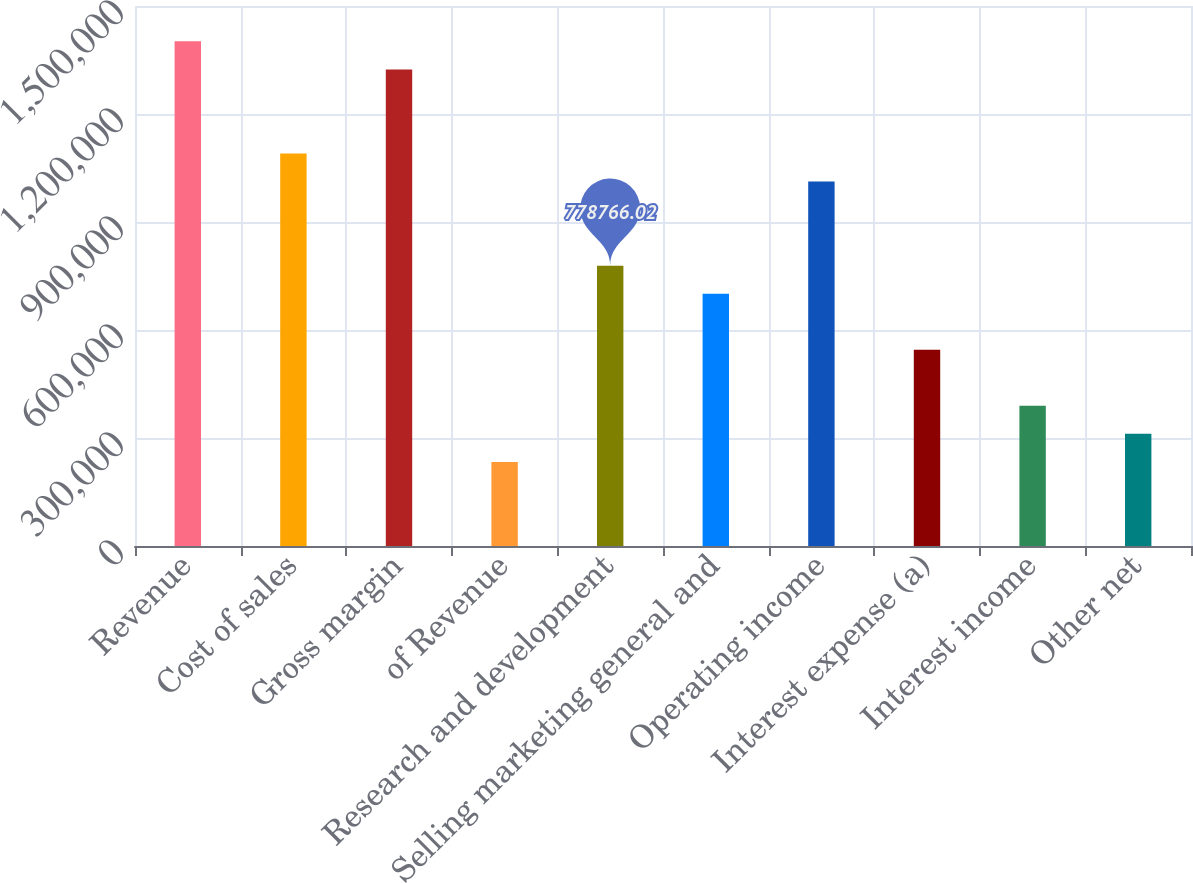Convert chart. <chart><loc_0><loc_0><loc_500><loc_500><bar_chart><fcel>Revenue<fcel>Cost of sales<fcel>Gross margin<fcel>of Revenue<fcel>Research and development<fcel>Selling marketing general and<fcel>Operating income<fcel>Interest expense (a)<fcel>Interest income<fcel>Other net<nl><fcel>1.40178e+06<fcel>1.09027e+06<fcel>1.3239e+06<fcel>233630<fcel>778766<fcel>700889<fcel>1.0124e+06<fcel>545136<fcel>389383<fcel>311507<nl></chart> 